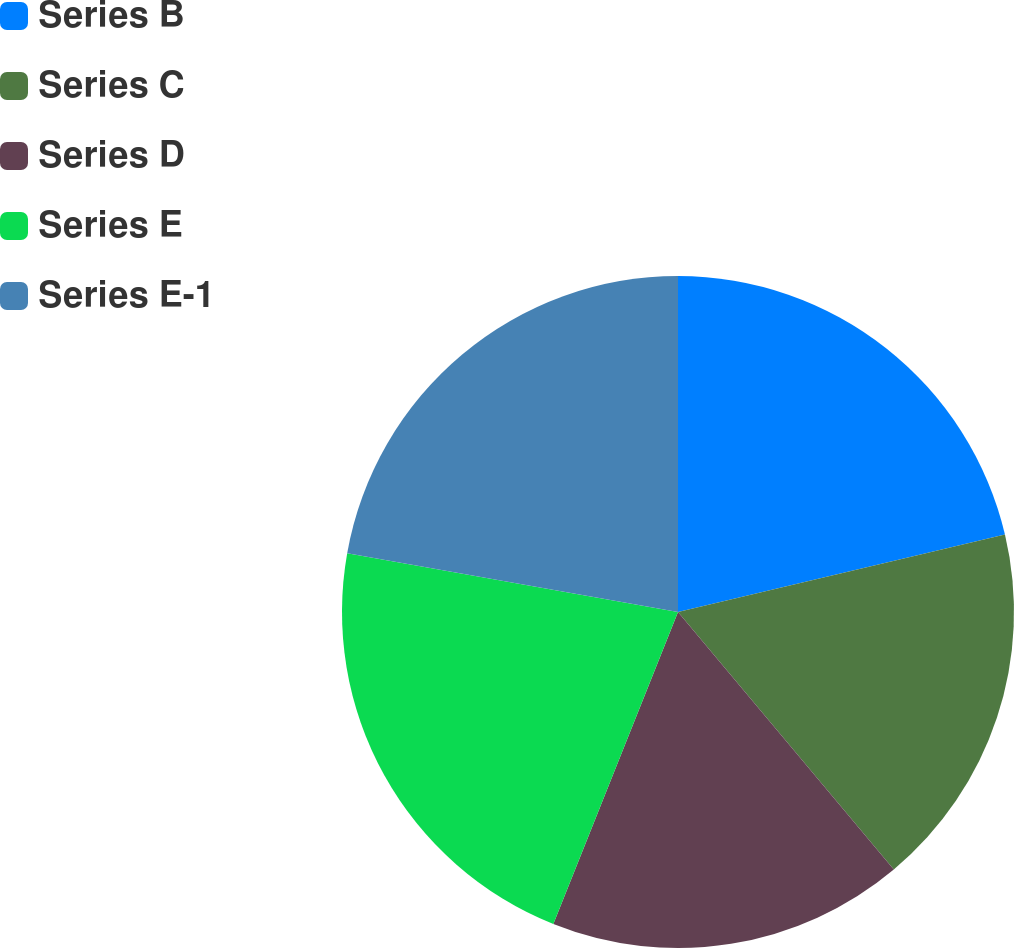Convert chart. <chart><loc_0><loc_0><loc_500><loc_500><pie_chart><fcel>Series B<fcel>Series C<fcel>Series D<fcel>Series E<fcel>Series E-1<nl><fcel>21.3%<fcel>17.6%<fcel>17.15%<fcel>21.75%<fcel>22.2%<nl></chart> 